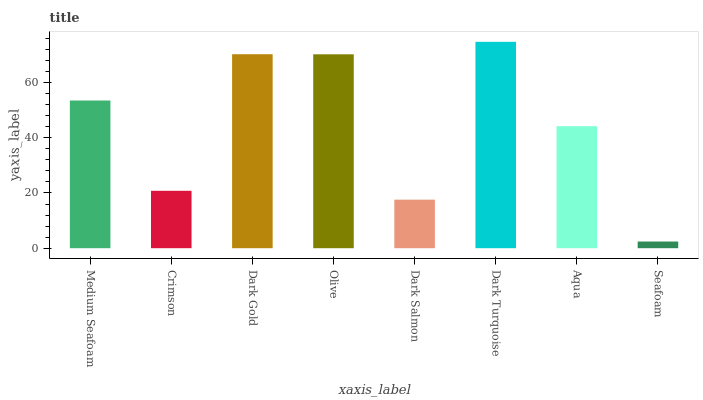Is Seafoam the minimum?
Answer yes or no. Yes. Is Dark Turquoise the maximum?
Answer yes or no. Yes. Is Crimson the minimum?
Answer yes or no. No. Is Crimson the maximum?
Answer yes or no. No. Is Medium Seafoam greater than Crimson?
Answer yes or no. Yes. Is Crimson less than Medium Seafoam?
Answer yes or no. Yes. Is Crimson greater than Medium Seafoam?
Answer yes or no. No. Is Medium Seafoam less than Crimson?
Answer yes or no. No. Is Medium Seafoam the high median?
Answer yes or no. Yes. Is Aqua the low median?
Answer yes or no. Yes. Is Dark Turquoise the high median?
Answer yes or no. No. Is Dark Gold the low median?
Answer yes or no. No. 